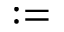Convert formula to latex. <formula><loc_0><loc_0><loc_500><loc_500>\colon =</formula> 